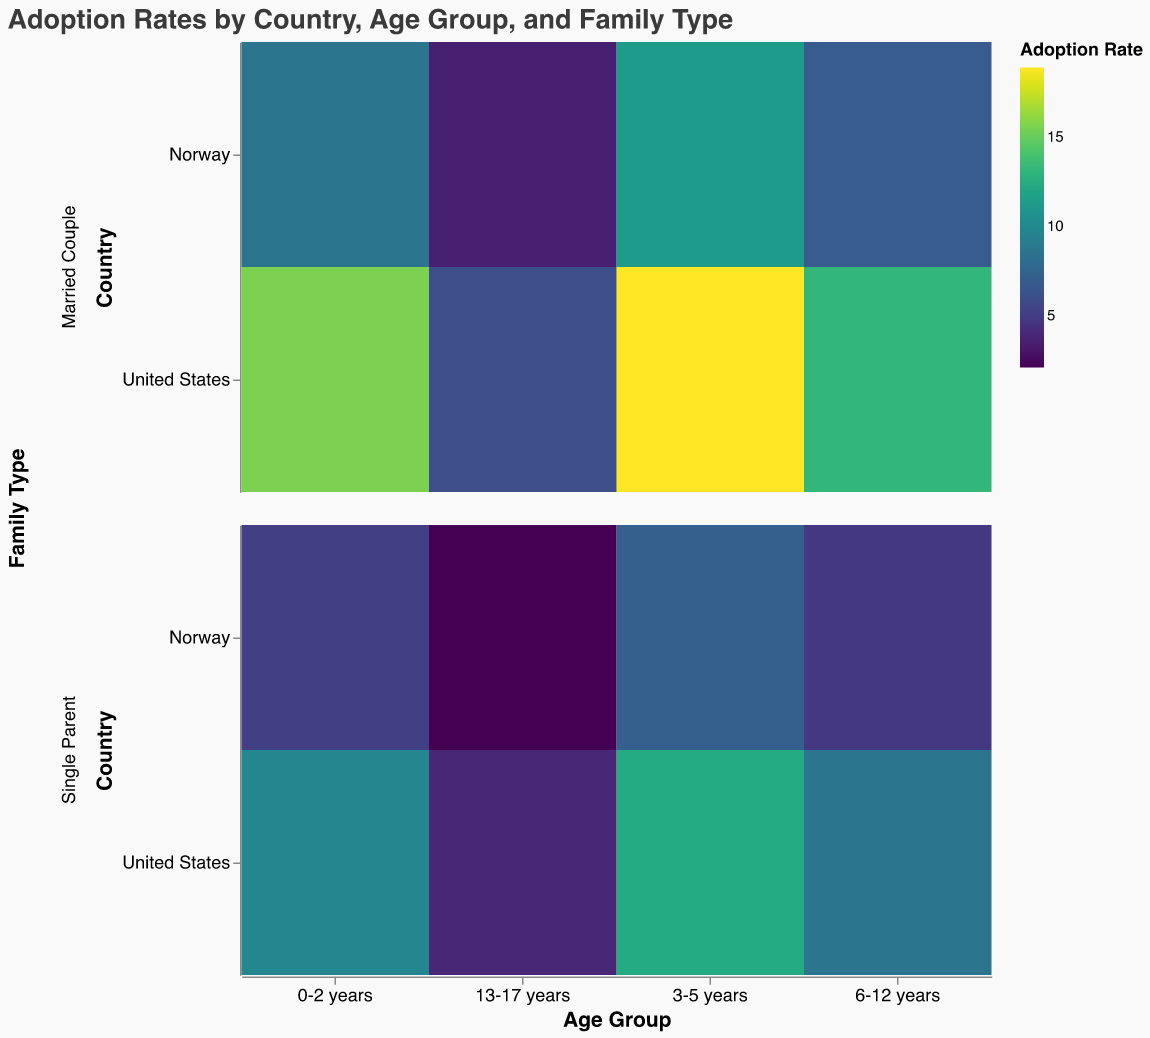Which country has a higher adoption rate for children aged 0-2 years with married couples? Refer to the color intensity and size of the rectangles in the row for married couples and the column for 0-2 years. The United States has a more intense color and larger size compared to Norway in this category.
Answer: United States Which family type has a higher adoption rate in Norway for the age group 3-5 years? Compare the colors and sizes of the rectangles for Norway within the 3-5 years column. The rectangle for married couples has a more intense color and larger size than that for single parents.
Answer: Married Couple What is the adoption rate difference between the United States and Norway for the age group 6-12 years among single parents? Subtract the adoption rate of Norway from that of the United States for single parents within the 6-12 years column: 8.7 - 4.8 = 3.9.
Answer: 3.9 Are single parents or married couples more likely to adopt children aged 13-17 years in the United States? Compare the color intensity and size of the rectangles in the United States row for the age group 13-17 years. Married couples have a more intense color and larger size than single parents.
Answer: Married Couple Which country has the lowest adoption rate for children aged 13-17 years among single parents? Compare the color intensity and size of rectangles in the 13-17 years column for single parents in both countries. Norway's rectangle is less intense and smaller.
Answer: Norway What is the sum of the adoption rates for married couples in Norway across all age groups? Sum the adoption rates for married couples in Norway: 8.7 + 11.3 + 6.9 + 3.5 = 30.4.
Answer: 30.4 How does the adoption rate for children aged 0-2 years with single parents in Norway compare to that in the United States? Compare the color and size for single parents in the 0-2 years column for both countries. The United States has a more intense color and larger size.
Answer: Lower in Norway What is the average adoption rate for married couples in the United States across all age groups? Calculate the average adoption rate for married couples in the United States: (15.6 + 18.9 + 13.2 + 6.1) / 4 = 13.45.
Answer: 13.45 For which age group is the adoption rate in Norway among single parents the highest? Compare the color and size of rectangles for single parents in Norway across all age groups. The 3-5 years group has the most intense color and largest size.
Answer: 3-5 years 